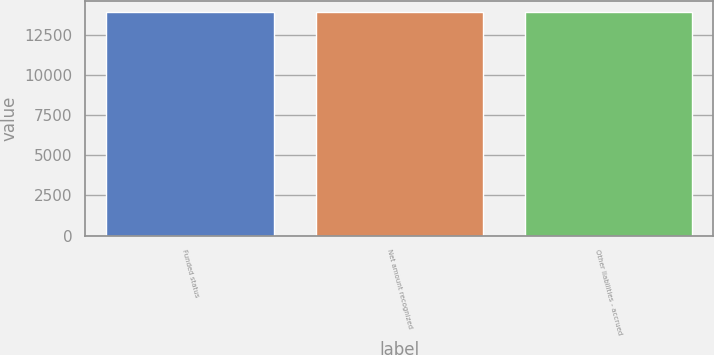Convert chart. <chart><loc_0><loc_0><loc_500><loc_500><bar_chart><fcel>Funded status<fcel>Net amount recognized<fcel>Other liabilities - accrued<nl><fcel>13900<fcel>13900.1<fcel>13900.2<nl></chart> 